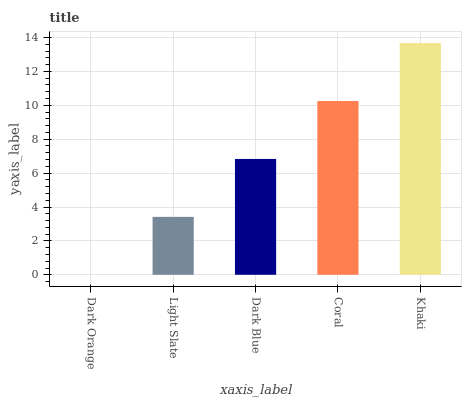Is Dark Orange the minimum?
Answer yes or no. Yes. Is Khaki the maximum?
Answer yes or no. Yes. Is Light Slate the minimum?
Answer yes or no. No. Is Light Slate the maximum?
Answer yes or no. No. Is Light Slate greater than Dark Orange?
Answer yes or no. Yes. Is Dark Orange less than Light Slate?
Answer yes or no. Yes. Is Dark Orange greater than Light Slate?
Answer yes or no. No. Is Light Slate less than Dark Orange?
Answer yes or no. No. Is Dark Blue the high median?
Answer yes or no. Yes. Is Dark Blue the low median?
Answer yes or no. Yes. Is Coral the high median?
Answer yes or no. No. Is Light Slate the low median?
Answer yes or no. No. 